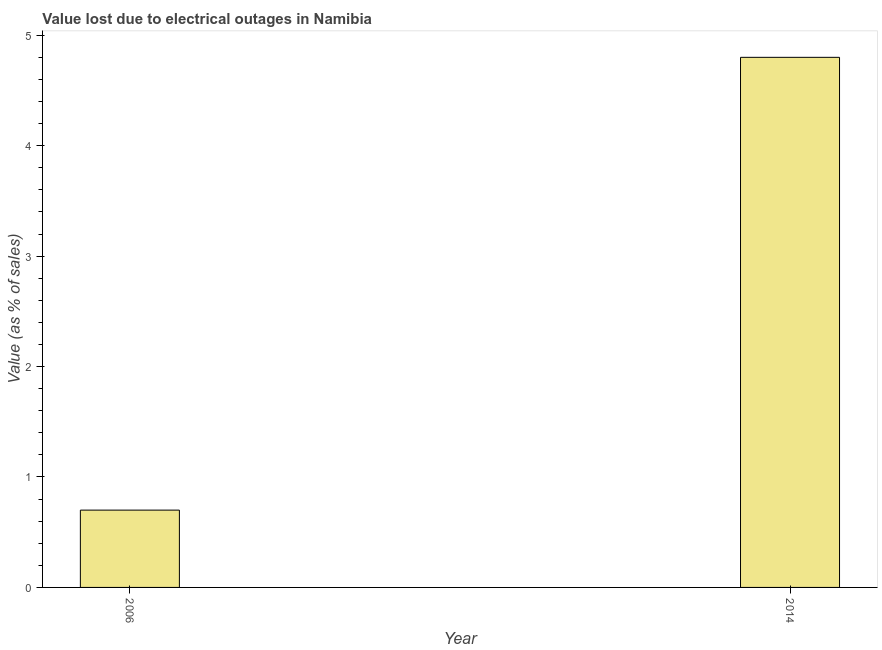Does the graph contain any zero values?
Your response must be concise. No. Does the graph contain grids?
Provide a succinct answer. No. What is the title of the graph?
Your answer should be compact. Value lost due to electrical outages in Namibia. What is the label or title of the Y-axis?
Your answer should be very brief. Value (as % of sales). Across all years, what is the maximum value lost due to electrical outages?
Your answer should be very brief. 4.8. Across all years, what is the minimum value lost due to electrical outages?
Provide a succinct answer. 0.7. What is the sum of the value lost due to electrical outages?
Your answer should be very brief. 5.5. What is the difference between the value lost due to electrical outages in 2006 and 2014?
Keep it short and to the point. -4.1. What is the average value lost due to electrical outages per year?
Give a very brief answer. 2.75. What is the median value lost due to electrical outages?
Give a very brief answer. 2.75. In how many years, is the value lost due to electrical outages greater than 1 %?
Your answer should be compact. 1. Do a majority of the years between 2014 and 2006 (inclusive) have value lost due to electrical outages greater than 2.6 %?
Your answer should be compact. No. What is the ratio of the value lost due to electrical outages in 2006 to that in 2014?
Give a very brief answer. 0.15. Are all the bars in the graph horizontal?
Your answer should be compact. No. How many years are there in the graph?
Offer a very short reply. 2. What is the difference between two consecutive major ticks on the Y-axis?
Your answer should be compact. 1. Are the values on the major ticks of Y-axis written in scientific E-notation?
Provide a succinct answer. No. What is the ratio of the Value (as % of sales) in 2006 to that in 2014?
Keep it short and to the point. 0.15. 